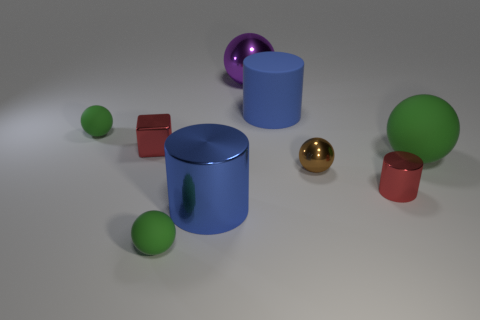Subtract all blue cubes. How many green spheres are left? 3 Subtract 2 spheres. How many spheres are left? 3 Subtract all brown metal balls. How many balls are left? 4 Subtract all brown balls. Subtract all brown cylinders. How many balls are left? 4 Add 1 small purple matte spheres. How many objects exist? 10 Subtract all cylinders. How many objects are left? 6 Subtract all big yellow balls. Subtract all blue metallic cylinders. How many objects are left? 8 Add 5 big rubber cylinders. How many big rubber cylinders are left? 6 Add 1 big cyan cylinders. How many big cyan cylinders exist? 1 Subtract 0 purple cylinders. How many objects are left? 9 